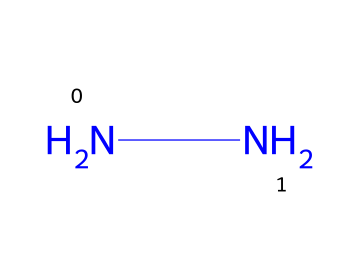How many nitrogen atoms are present in this chemical? The SMILES representation "NN" indicates that there are two nitrogen atoms connected to each other. Each "N" represents a nitrogen atom.
Answer: 2 What type of functional group is present in this structure? The presence of two nitrogen atoms bonded together without any other atoms or functional groups indicates that this is a hydrazine functional group.
Answer: hydrazine What is the molecular formula of this chemical? Since there are two nitrogen atoms and no other elements present, the molecular formula can be represented as N2H4 because hydrazines typically have two nitrogen atoms and four hydrogen atoms.
Answer: N2H4 What is the primary use of hydrazine in space exploration? Hydrazine is commonly used as a rocket fuel due to its high energy content and ability to provide thrust in propulsion systems.
Answer: rocket fuel Is this chemical considered to be toxic? Yes, hydrazine is known to be highly toxic and can pose serious health risks if not handled properly.
Answer: yes What are the oxidation states of nitrogen in this hydrazine structure? In hydrazine, the oxidation state of nitrogen is -2, indicating a reduced state compared to its elemental form.
Answer: -2 Can this chemical undergo self-propagating decomposition? Yes, hydrazine can undergo self-propagating decomposition, leading to the release of energy and gases rapidly under certain conditions.
Answer: yes 